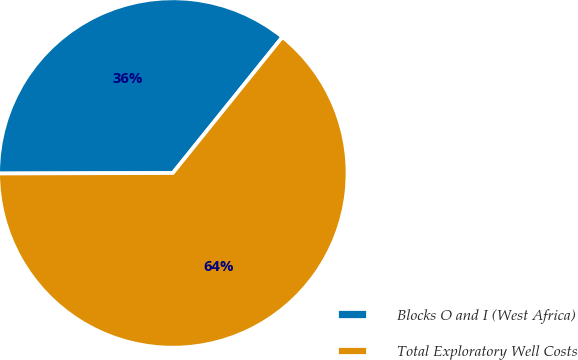Convert chart to OTSL. <chart><loc_0><loc_0><loc_500><loc_500><pie_chart><fcel>Blocks O and I (West Africa)<fcel>Total Exploratory Well Costs<nl><fcel>35.84%<fcel>64.16%<nl></chart> 